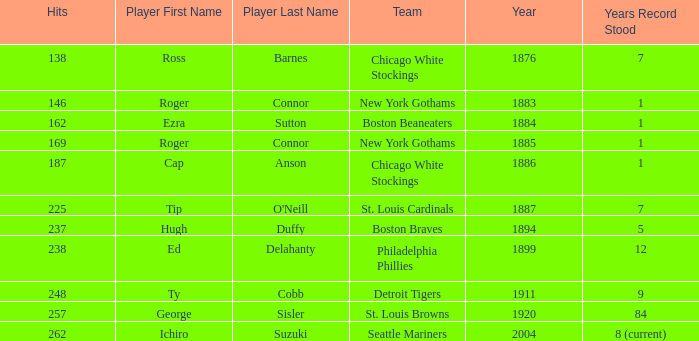Name the hits for years before 1883 138.0. 